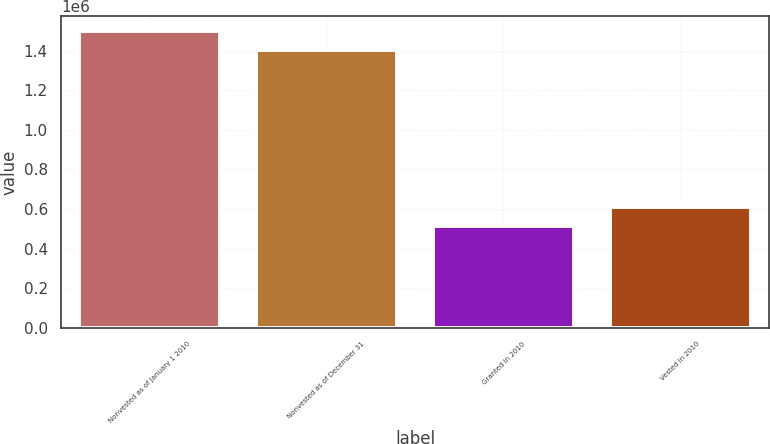Convert chart. <chart><loc_0><loc_0><loc_500><loc_500><bar_chart><fcel>Nonvested as of January 1 2010<fcel>Nonvested as of December 31<fcel>Granted in 2010<fcel>Vested in 2010<nl><fcel>1.49988e+06<fcel>1.40211e+06<fcel>511418<fcel>609195<nl></chart> 